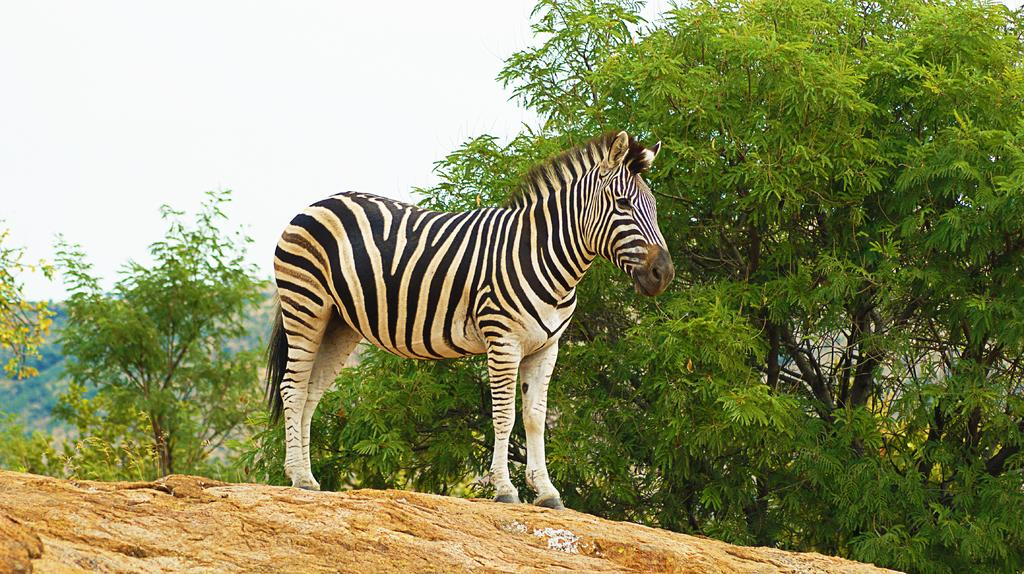What animal is the main subject of the image? There is a zebra in the image. What colors are present on the zebra? The zebra is in black and white color. What can be seen in the background of the image? There are trees and the sky visible in the background of the image. What color are the trees in the image? The trees are in green color. What color is the sky in the image? The sky is in white color. Where are the cats sitting on the sofa in the image? There are no cats or sofa present in the image; it features a zebra with trees and a white sky in the background. 